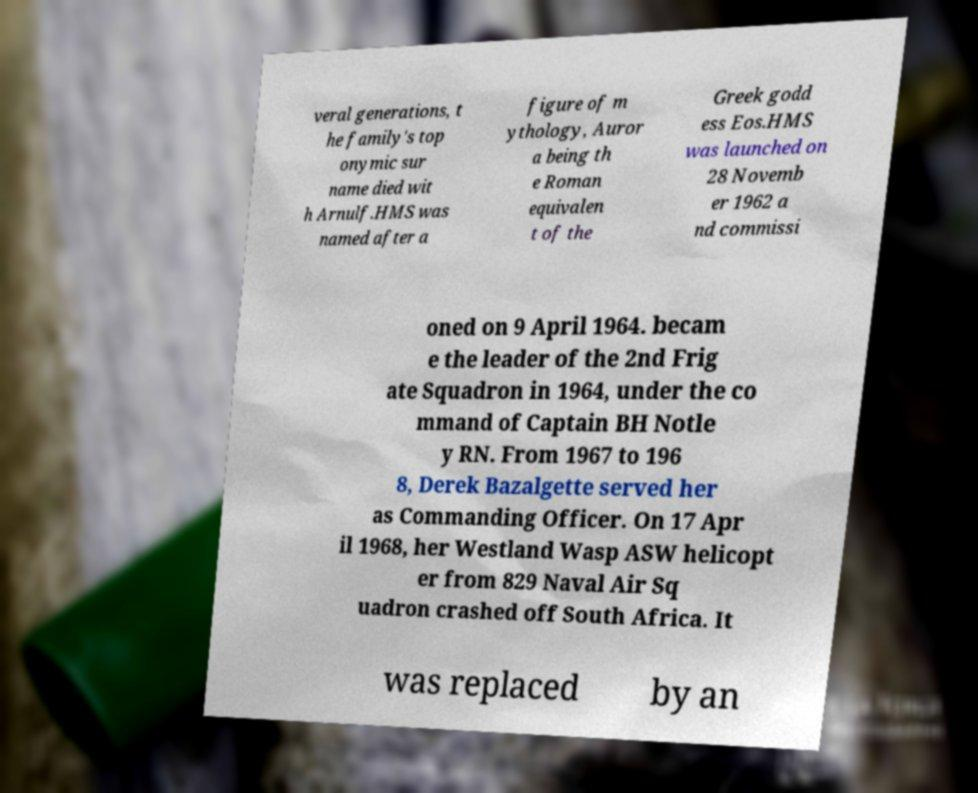There's text embedded in this image that I need extracted. Can you transcribe it verbatim? veral generations, t he family's top onymic sur name died wit h Arnulf.HMS was named after a figure of m ythology, Auror a being th e Roman equivalen t of the Greek godd ess Eos.HMS was launched on 28 Novemb er 1962 a nd commissi oned on 9 April 1964. becam e the leader of the 2nd Frig ate Squadron in 1964, under the co mmand of Captain BH Notle y RN. From 1967 to 196 8, Derek Bazalgette served her as Commanding Officer. On 17 Apr il 1968, her Westland Wasp ASW helicopt er from 829 Naval Air Sq uadron crashed off South Africa. It was replaced by an 